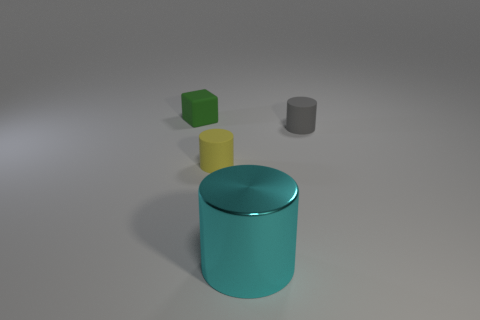Add 3 tiny blocks. How many objects exist? 7 Subtract all blocks. How many objects are left? 3 Add 2 brown rubber things. How many brown rubber things exist? 2 Subtract 0 red blocks. How many objects are left? 4 Subtract all objects. Subtract all blue rubber spheres. How many objects are left? 0 Add 2 tiny rubber cylinders. How many tiny rubber cylinders are left? 4 